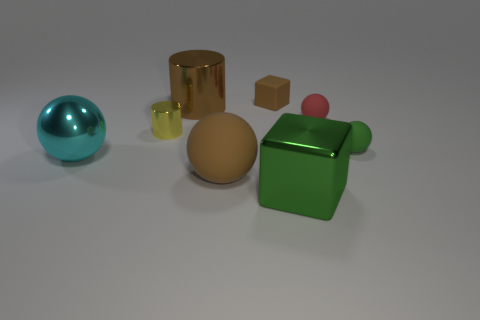Subtract 1 balls. How many balls are left? 3 Add 1 small green cylinders. How many objects exist? 9 Subtract all cylinders. How many objects are left? 6 Subtract 1 cyan balls. How many objects are left? 7 Subtract all small red matte balls. Subtract all yellow metal cubes. How many objects are left? 7 Add 8 small matte balls. How many small matte balls are left? 10 Add 3 green matte objects. How many green matte objects exist? 4 